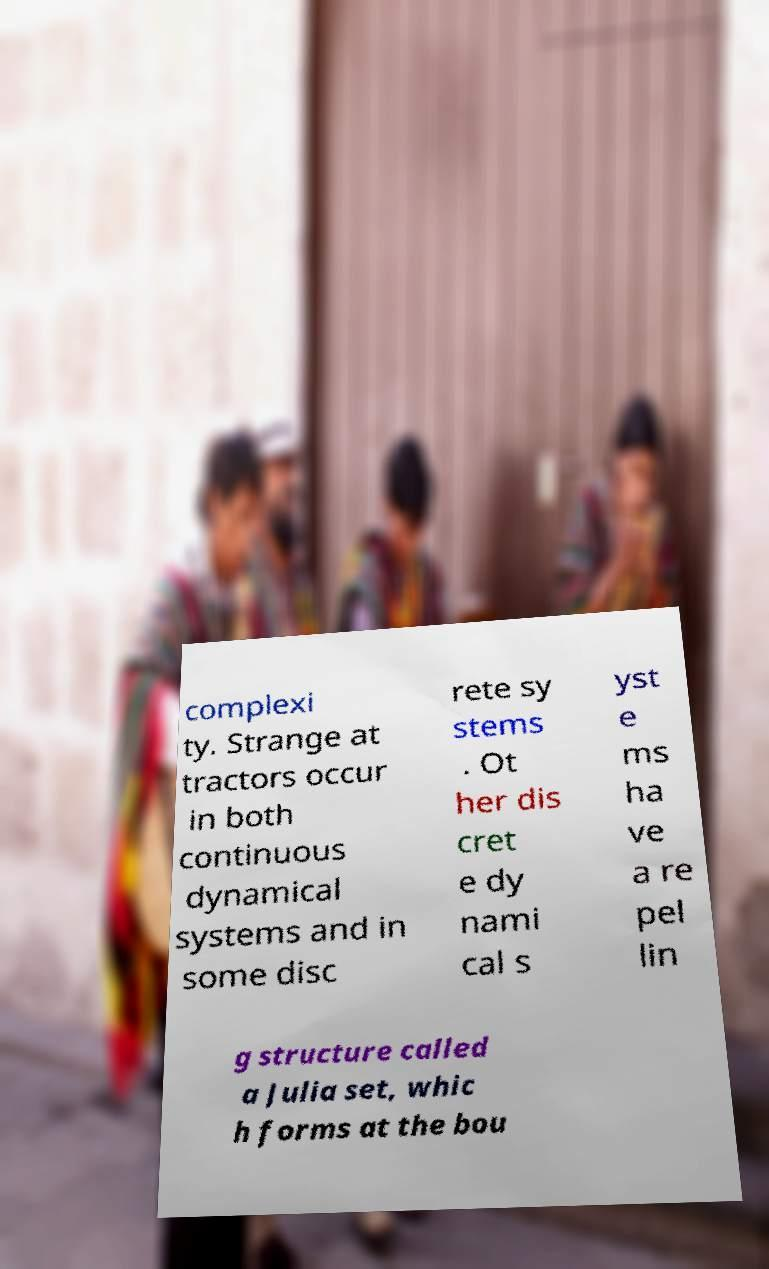What messages or text are displayed in this image? I need them in a readable, typed format. complexi ty. Strange at tractors occur in both continuous dynamical systems and in some disc rete sy stems . Ot her dis cret e dy nami cal s yst e ms ha ve a re pel lin g structure called a Julia set, whic h forms at the bou 